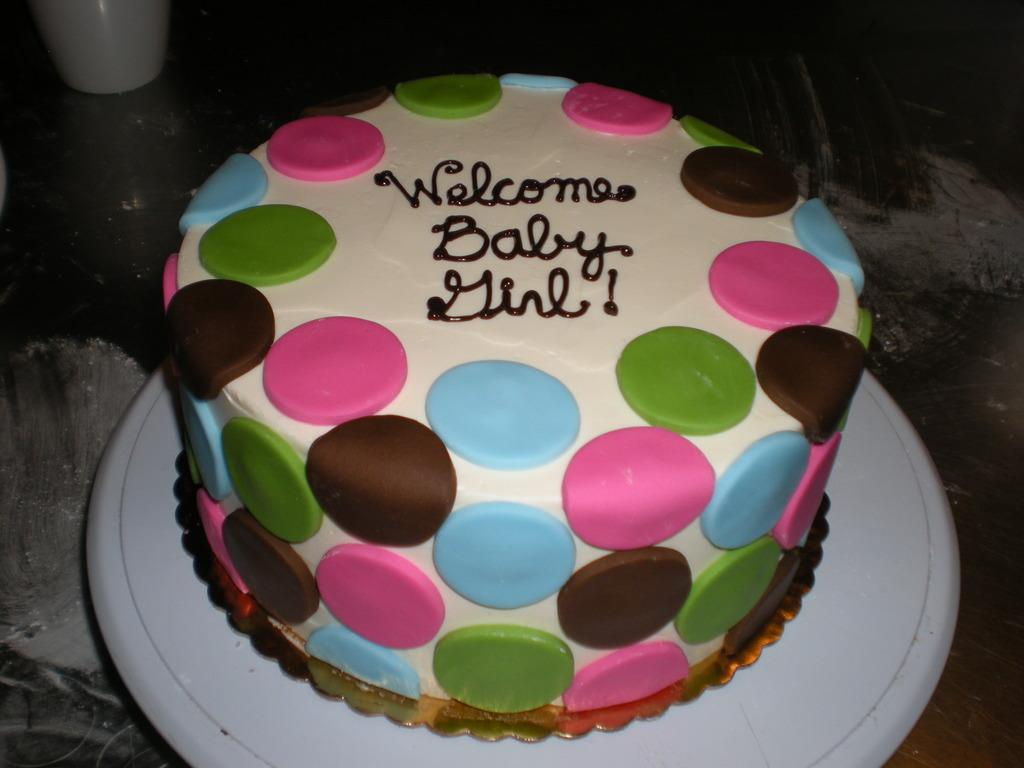What is the main subject of the image? There is a cake in the image. What is the cake placed on? The cake is on a white object. What type of cork is used to decorate the cake in the image? There is no cork present on the cake in the image. How is the string used to hold the cake together in the image? There is no string present on the cake in the image. 